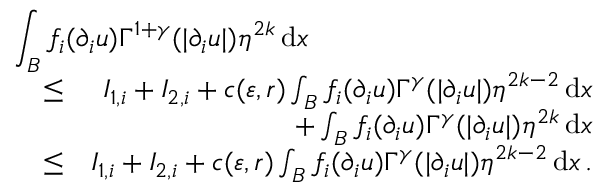<formula> <loc_0><loc_0><loc_500><loc_500>\begin{array} { r l r } { { \int _ { B } f _ { i } ( \partial _ { i } u ) \Gamma ^ { 1 + \gamma } ( | \partial _ { i } u | ) \eta ^ { 2 k } \, d x } } \\ & { \leq } & { I _ { 1 , i } + I _ { 2 , i } + c ( \varepsilon , r ) \int _ { B } f _ { i } ( \partial _ { i } u ) \Gamma ^ { \gamma } ( | \partial _ { i } u | ) \eta ^ { 2 k - 2 } \, d x } \\ & { + \int _ { B } f _ { i } ( \partial _ { i } u ) \Gamma ^ { \gamma } ( | \partial _ { i } u | ) \eta ^ { 2 k } \, d x } \\ & { \leq } & { I _ { 1 , i } + I _ { 2 , i } + c ( \varepsilon , r ) \int _ { B } f _ { i } ( \partial _ { i } u ) \Gamma ^ { \gamma } ( | \partial _ { i } u | ) \eta ^ { 2 k - 2 } \, d x \, . } \end{array}</formula> 